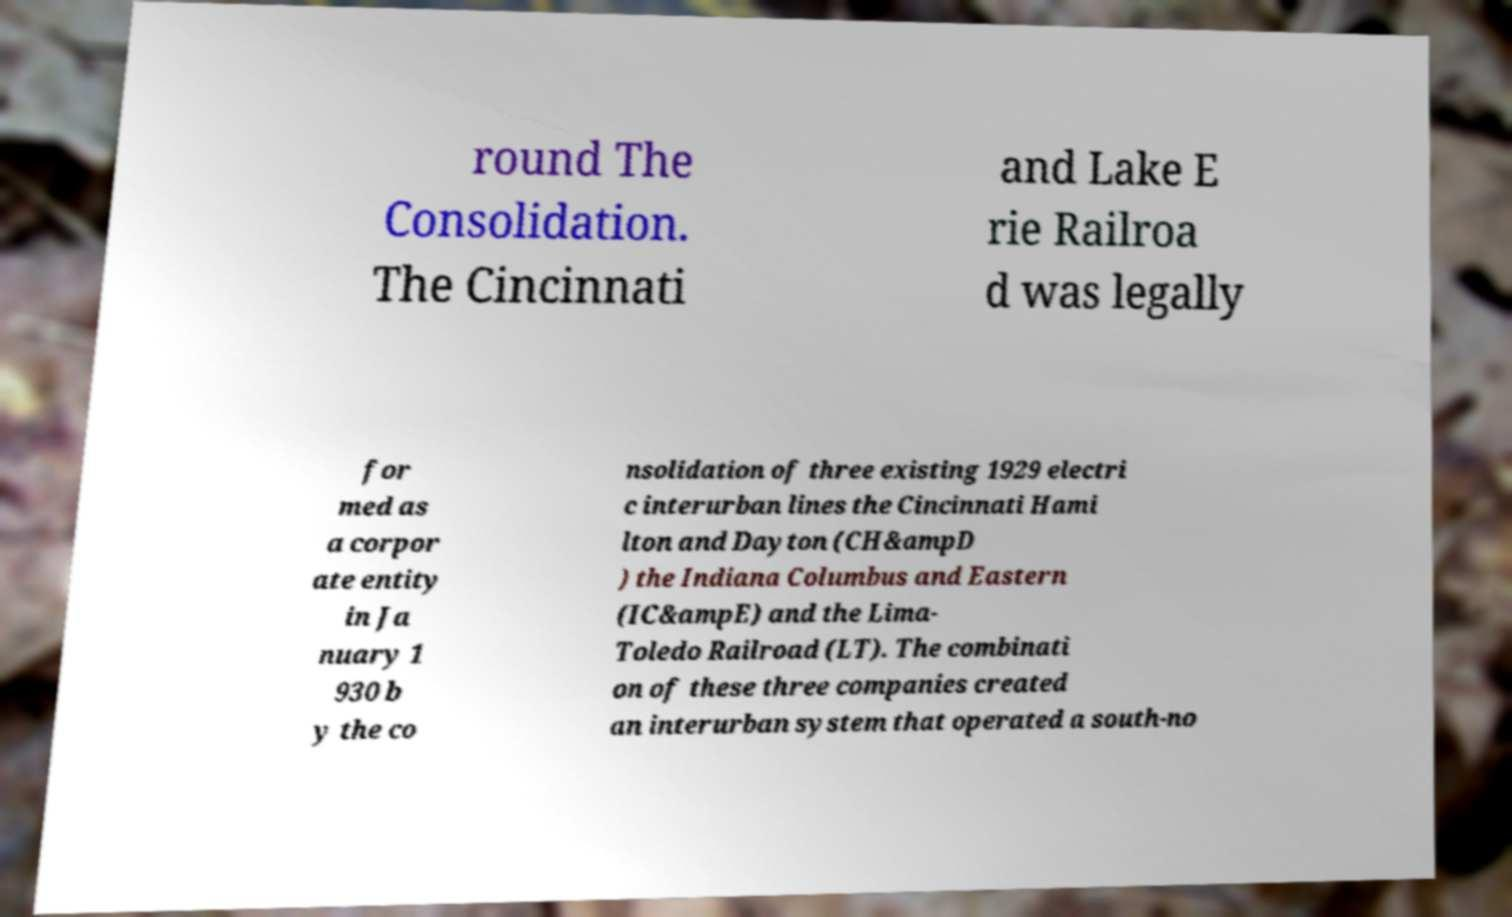Can you read and provide the text displayed in the image?This photo seems to have some interesting text. Can you extract and type it out for me? round The Consolidation. The Cincinnati and Lake E rie Railroa d was legally for med as a corpor ate entity in Ja nuary 1 930 b y the co nsolidation of three existing 1929 electri c interurban lines the Cincinnati Hami lton and Dayton (CH&ampD ) the Indiana Columbus and Eastern (IC&ampE) and the Lima- Toledo Railroad (LT). The combinati on of these three companies created an interurban system that operated a south-no 